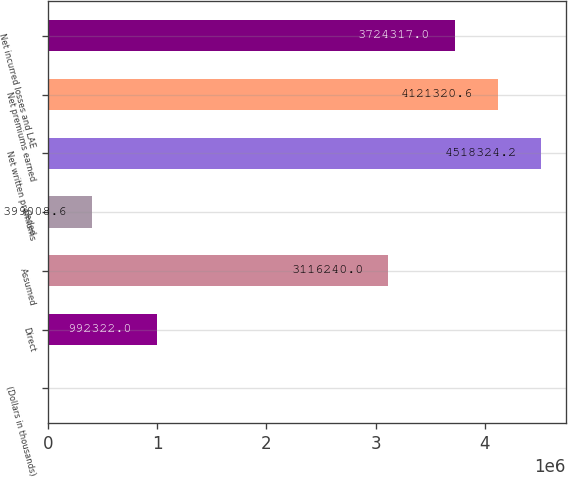Convert chart to OTSL. <chart><loc_0><loc_0><loc_500><loc_500><bar_chart><fcel>(Dollars in thousands)<fcel>Direct<fcel>Assumed<fcel>Ceded<fcel>Net written premiums<fcel>Net premiums earned<fcel>Net incurred losses and LAE<nl><fcel>2005<fcel>992322<fcel>3.11624e+06<fcel>399009<fcel>4.51832e+06<fcel>4.12132e+06<fcel>3.72432e+06<nl></chart> 